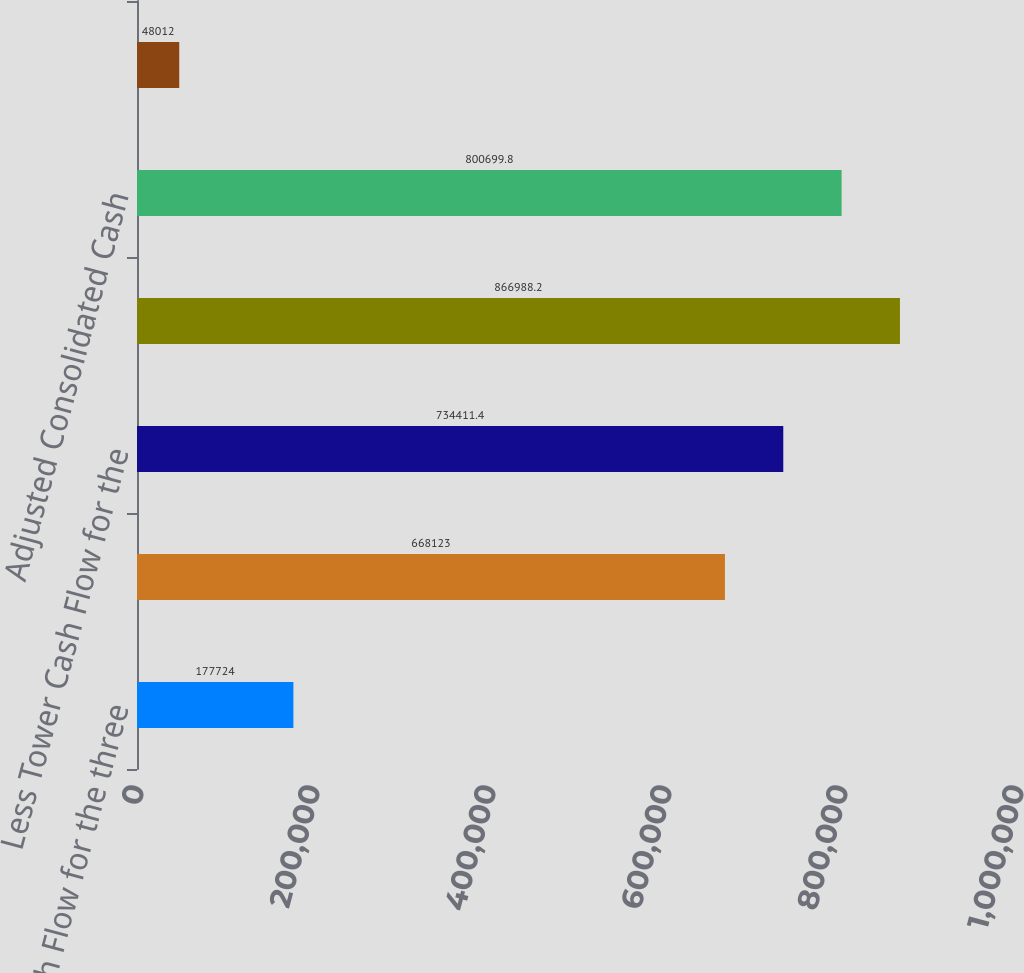Convert chart to OTSL. <chart><loc_0><loc_0><loc_500><loc_500><bar_chart><fcel>Tower Cash Flow for the three<fcel>Consolidated Cash Flow for the<fcel>Less Tower Cash Flow for the<fcel>Plus four times Tower Cash<fcel>Adjusted Consolidated Cash<fcel>Non-Tower Cash Flow for the<nl><fcel>177724<fcel>668123<fcel>734411<fcel>866988<fcel>800700<fcel>48012<nl></chart> 